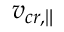<formula> <loc_0><loc_0><loc_500><loc_500>v _ { c r , \| }</formula> 